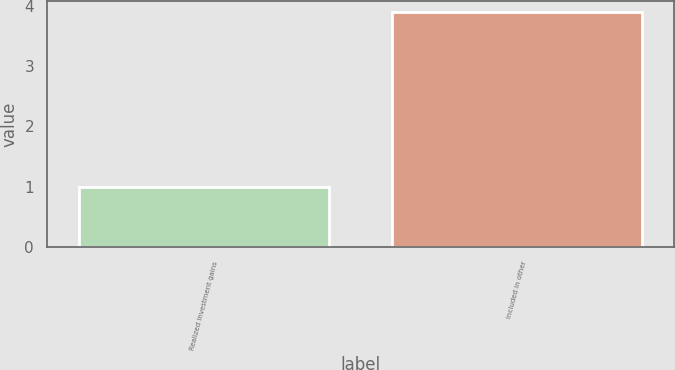Convert chart to OTSL. <chart><loc_0><loc_0><loc_500><loc_500><bar_chart><fcel>Realized investment gains<fcel>Included in other<nl><fcel>1<fcel>3.89<nl></chart> 